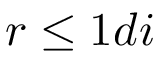Convert formula to latex. <formula><loc_0><loc_0><loc_500><loc_500>r \leq 1 d i</formula> 